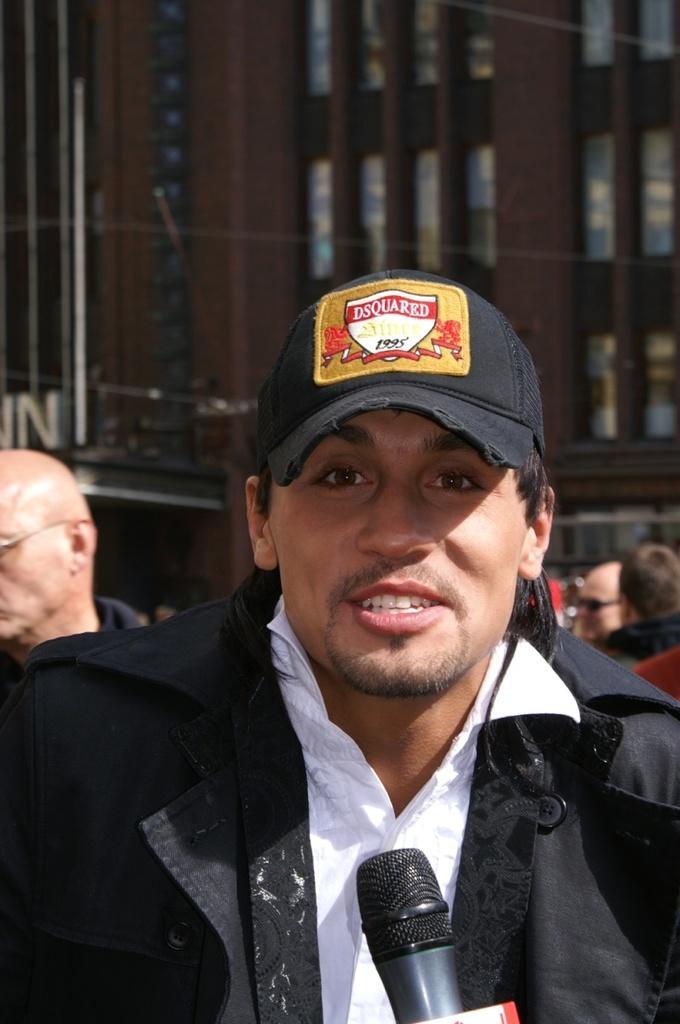Describe this image in one or two sentences. In this image we can see a few people, there is a mic, also we can see the building, and windows. 